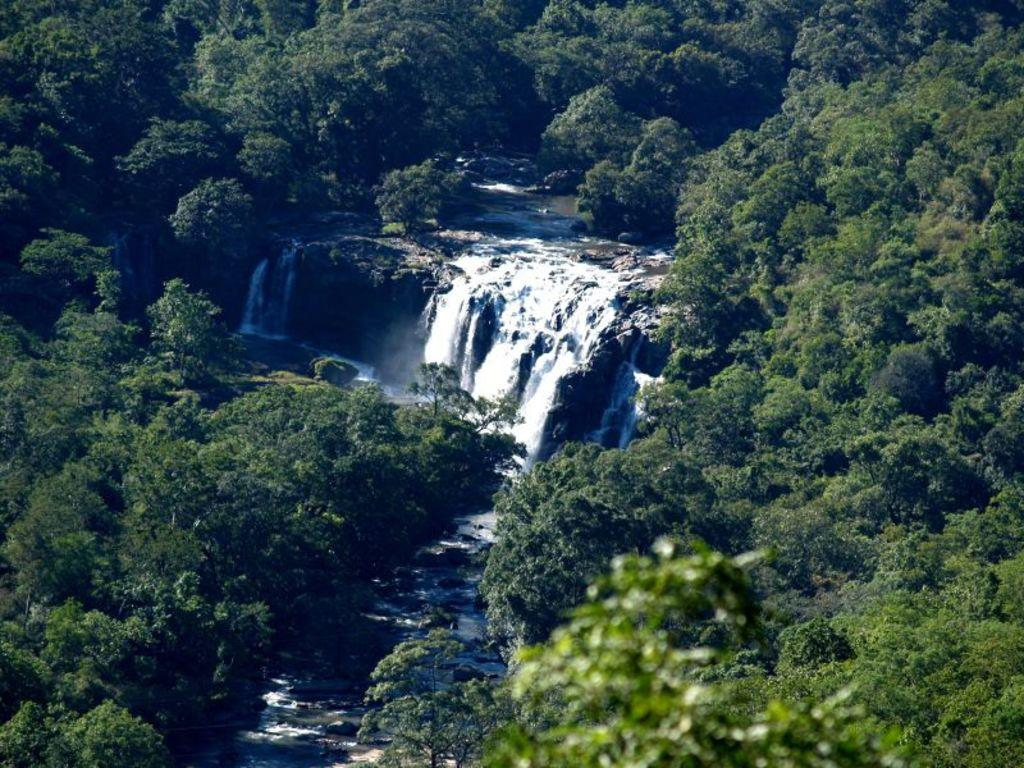What is the main feature in the center of the image? There is a waterfall in the center of the image. What can be seen in the background of the image? There are trees in the background of the image. What type of juice is being served in the waterfall? There is no juice or any indication of serving in the image; it features a waterfall and trees. Can you see any toes near the waterfall? There are no toes or people visible in the image; it only shows a waterfall and trees. 